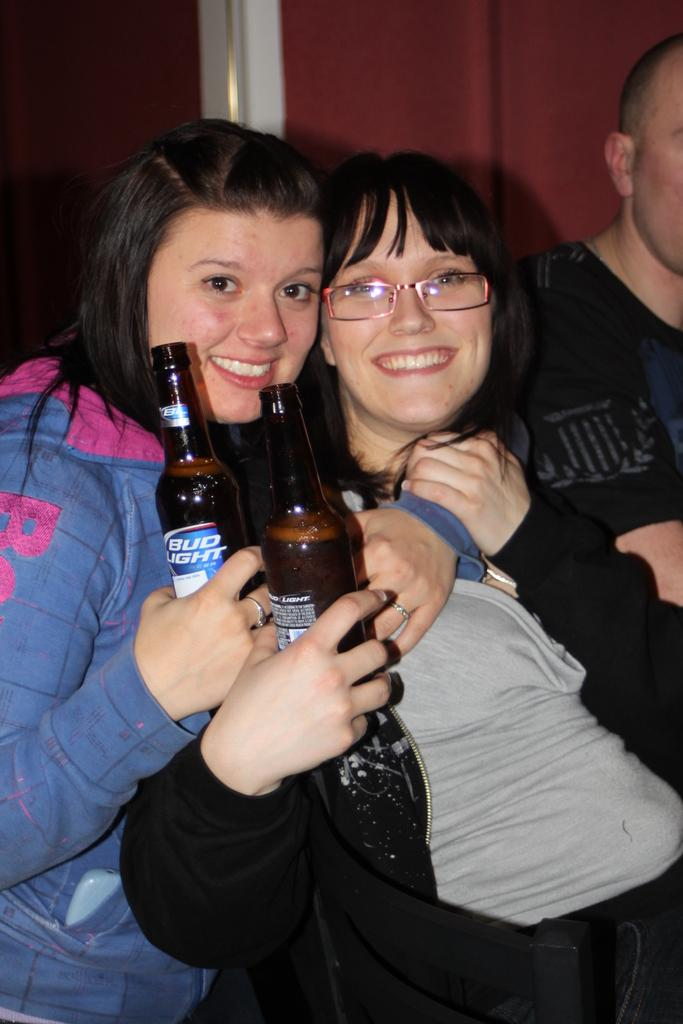How many people are present in the room? There are three people in the room. Where are the majority of people located in the room? Two people are in the center of the room. What are the expressions of the people in the center? Both people in the center are smiling. What are the people in the center holding? Both people in the center are holding bottles. Are there any women involved in the argument in the image? There is no argument present in the image, and no women are mentioned in the provided facts. 